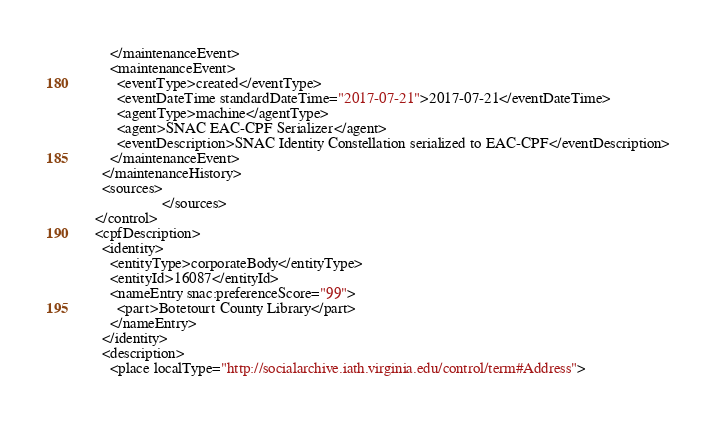Convert code to text. <code><loc_0><loc_0><loc_500><loc_500><_XML_>      </maintenanceEvent>
      <maintenanceEvent>
        <eventType>created</eventType>
        <eventDateTime standardDateTime="2017-07-21">2017-07-21</eventDateTime>
        <agentType>machine</agentType>
        <agent>SNAC EAC-CPF Serializer</agent>
        <eventDescription>SNAC Identity Constellation serialized to EAC-CPF</eventDescription>
      </maintenanceEvent>
    </maintenanceHistory>
    <sources>
                    </sources>
  </control>
  <cpfDescription>
    <identity>
      <entityType>corporateBody</entityType>
      <entityId>16087</entityId>
      <nameEntry snac:preferenceScore="99">
        <part>Botetourt County Library</part>
      </nameEntry>
    </identity>
    <description>
      <place localType="http://socialarchive.iath.virginia.edu/control/term#Address"></code> 